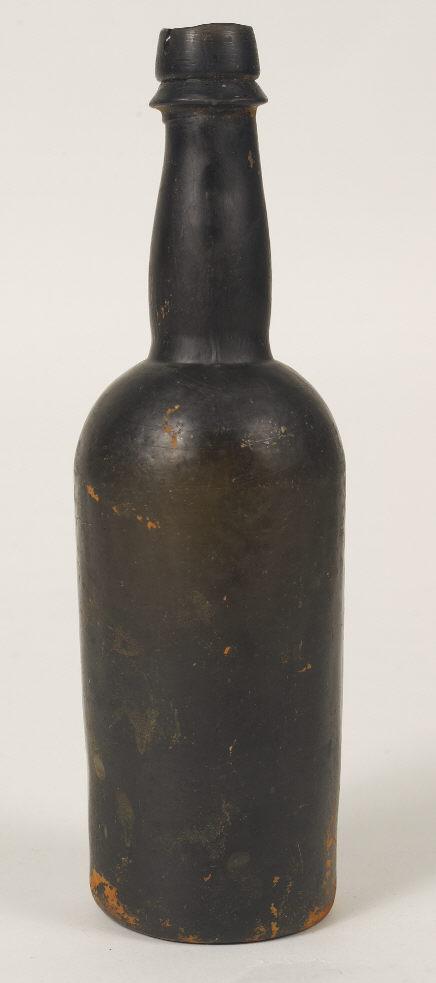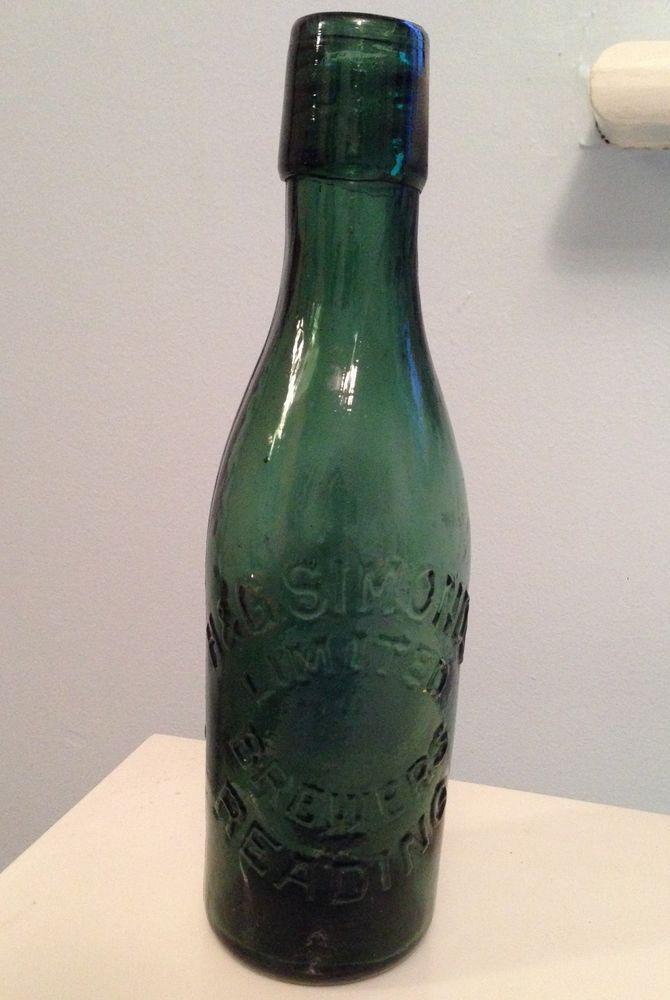The first image is the image on the left, the second image is the image on the right. For the images shown, is this caption "In one image, three brown bottles have wide, squat bodies, and a small, rimmed top edge." true? Answer yes or no. No. 